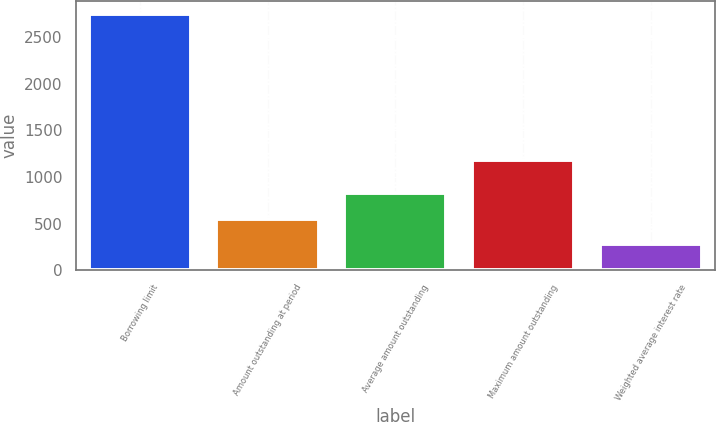Convert chart. <chart><loc_0><loc_0><loc_500><loc_500><bar_chart><fcel>Borrowing limit<fcel>Amount outstanding at period<fcel>Average amount outstanding<fcel>Maximum amount outstanding<fcel>Weighted average interest rate<nl><fcel>2750<fcel>550.6<fcel>825.53<fcel>1183<fcel>275.67<nl></chart> 